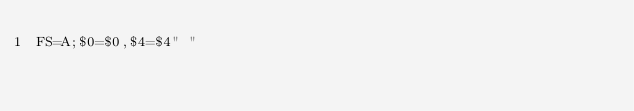<code> <loc_0><loc_0><loc_500><loc_500><_Awk_>FS=A;$0=$0,$4=$4" "</code> 